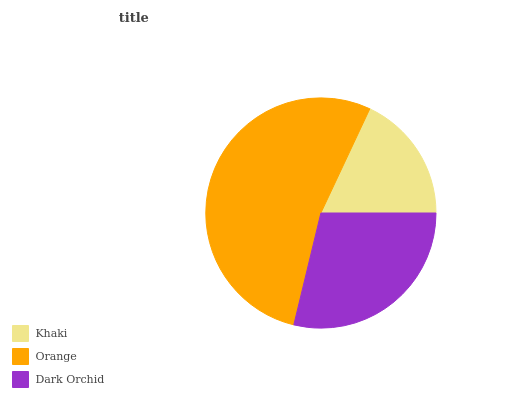Is Khaki the minimum?
Answer yes or no. Yes. Is Orange the maximum?
Answer yes or no. Yes. Is Dark Orchid the minimum?
Answer yes or no. No. Is Dark Orchid the maximum?
Answer yes or no. No. Is Orange greater than Dark Orchid?
Answer yes or no. Yes. Is Dark Orchid less than Orange?
Answer yes or no. Yes. Is Dark Orchid greater than Orange?
Answer yes or no. No. Is Orange less than Dark Orchid?
Answer yes or no. No. Is Dark Orchid the high median?
Answer yes or no. Yes. Is Dark Orchid the low median?
Answer yes or no. Yes. Is Khaki the high median?
Answer yes or no. No. Is Khaki the low median?
Answer yes or no. No. 